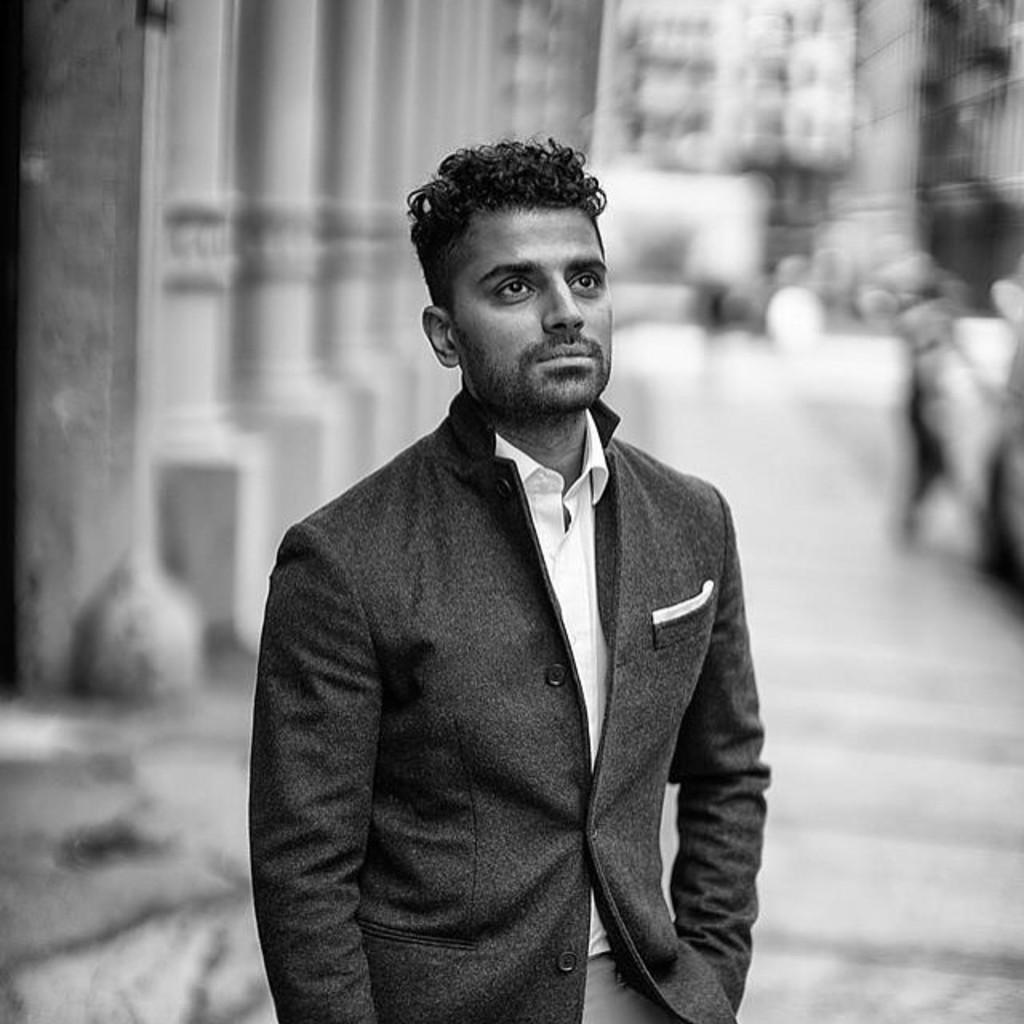Please provide a concise description of this image. In this image I can see a person standing and there is a blur background. 